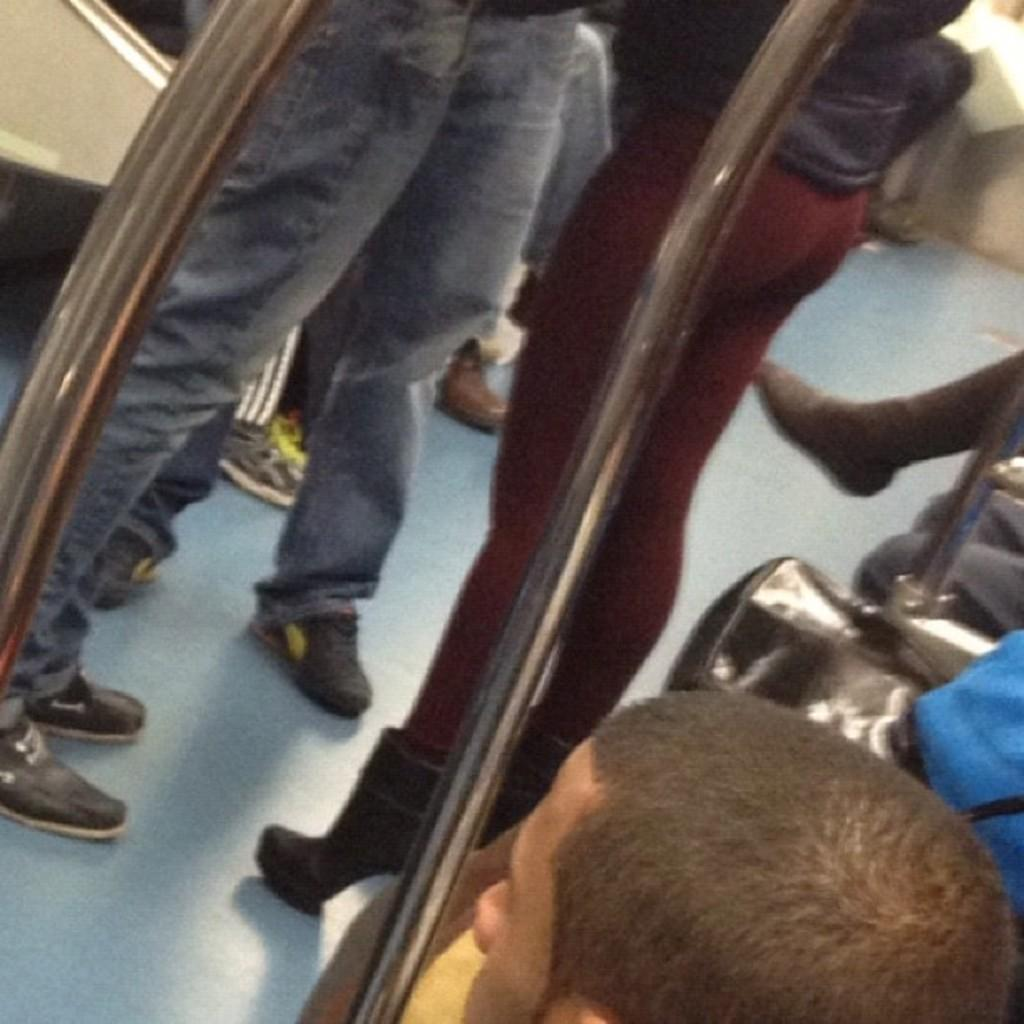How many people are in the image? There is a group of people in the image, but the exact number cannot be determined from the provided facts. What are some of the people in the image doing? Some people are standing, and some people are sitting on seats in the image. Where might the image have been taken? The image may have been taken inside a vehicle. What type of wilderness can be seen through the mouth of the person in the image? There is no person with a mouth visible in the image, and therefore no wilderness can be seen through it. 